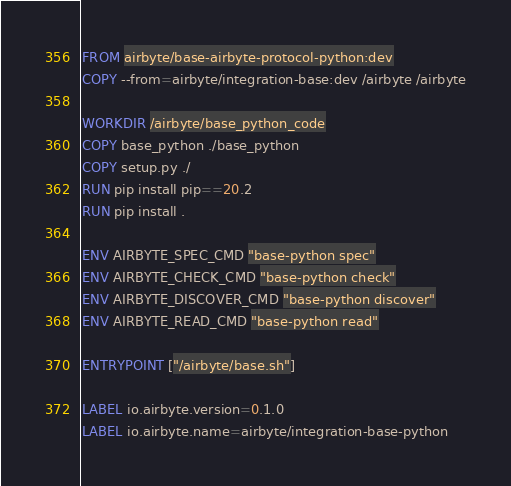Convert code to text. <code><loc_0><loc_0><loc_500><loc_500><_Dockerfile_>FROM airbyte/base-airbyte-protocol-python:dev
COPY --from=airbyte/integration-base:dev /airbyte /airbyte

WORKDIR /airbyte/base_python_code
COPY base_python ./base_python
COPY setup.py ./
RUN pip install pip==20.2
RUN pip install .

ENV AIRBYTE_SPEC_CMD "base-python spec"
ENV AIRBYTE_CHECK_CMD "base-python check"
ENV AIRBYTE_DISCOVER_CMD "base-python discover"
ENV AIRBYTE_READ_CMD "base-python read"

ENTRYPOINT ["/airbyte/base.sh"]

LABEL io.airbyte.version=0.1.0
LABEL io.airbyte.name=airbyte/integration-base-python
</code> 